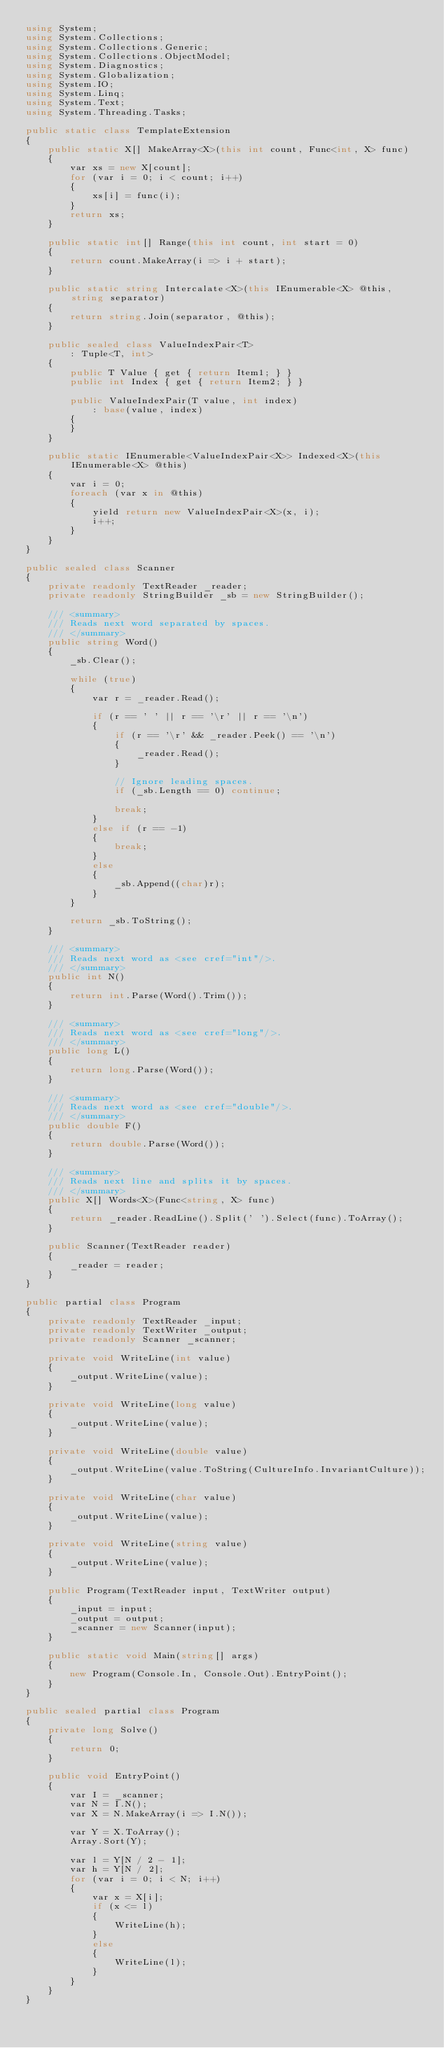<code> <loc_0><loc_0><loc_500><loc_500><_C#_>using System;
using System.Collections;
using System.Collections.Generic;
using System.Collections.ObjectModel;
using System.Diagnostics;
using System.Globalization;
using System.IO;
using System.Linq;
using System.Text;
using System.Threading.Tasks;

public static class TemplateExtension
{
    public static X[] MakeArray<X>(this int count, Func<int, X> func)
    {
        var xs = new X[count];
        for (var i = 0; i < count; i++)
        {
            xs[i] = func(i);
        }
        return xs;
    }

    public static int[] Range(this int count, int start = 0)
    {
        return count.MakeArray(i => i + start);
    }

    public static string Intercalate<X>(this IEnumerable<X> @this, string separator)
    {
        return string.Join(separator, @this);
    }

    public sealed class ValueIndexPair<T>
        : Tuple<T, int>
    {
        public T Value { get { return Item1; } }
        public int Index { get { return Item2; } }

        public ValueIndexPair(T value, int index)
            : base(value, index)
        {
        }
    }

    public static IEnumerable<ValueIndexPair<X>> Indexed<X>(this IEnumerable<X> @this)
    {
        var i = 0;
        foreach (var x in @this)
        {
            yield return new ValueIndexPair<X>(x, i);
            i++;
        }
    }
}

public sealed class Scanner
{
    private readonly TextReader _reader;
    private readonly StringBuilder _sb = new StringBuilder();

    /// <summary>
    /// Reads next word separated by spaces.
    /// </summary>
    public string Word()
    {
        _sb.Clear();

        while (true)
        {
            var r = _reader.Read();

            if (r == ' ' || r == '\r' || r == '\n')
            {
                if (r == '\r' && _reader.Peek() == '\n')
                {
                    _reader.Read();
                }

                // Ignore leading spaces.
                if (_sb.Length == 0) continue;

                break;
            }
            else if (r == -1)
            {
                break;
            }
            else
            {
                _sb.Append((char)r);
            }
        }

        return _sb.ToString();
    }

    /// <summary>
    /// Reads next word as <see cref="int"/>.
    /// </summary>
    public int N()
    {
        return int.Parse(Word().Trim());
    }

    /// <summary>
    /// Reads next word as <see cref="long"/>.
    /// </summary>
    public long L()
    {
        return long.Parse(Word());
    }

    /// <summary>
    /// Reads next word as <see cref="double"/>.
    /// </summary>
    public double F()
    {
        return double.Parse(Word());
    }

    /// <summary>
    /// Reads next line and splits it by spaces.
    /// </summary>
    public X[] Words<X>(Func<string, X> func)
    {
        return _reader.ReadLine().Split(' ').Select(func).ToArray();
    }

    public Scanner(TextReader reader)
    {
        _reader = reader;
    }
}

public partial class Program
{
    private readonly TextReader _input;
    private readonly TextWriter _output;
    private readonly Scanner _scanner;

    private void WriteLine(int value)
    {
        _output.WriteLine(value);
    }

    private void WriteLine(long value)
    {
        _output.WriteLine(value);
    }

    private void WriteLine(double value)
    {
        _output.WriteLine(value.ToString(CultureInfo.InvariantCulture));
    }

    private void WriteLine(char value)
    {
        _output.WriteLine(value);
    }

    private void WriteLine(string value)
    {
        _output.WriteLine(value);
    }

    public Program(TextReader input, TextWriter output)
    {
        _input = input;
        _output = output;
        _scanner = new Scanner(input);
    }

    public static void Main(string[] args)
    {
        new Program(Console.In, Console.Out).EntryPoint();
    }
}

public sealed partial class Program
{
    private long Solve()
    {
        return 0;
    }

    public void EntryPoint()
    {
        var I = _scanner;
        var N = I.N();
        var X = N.MakeArray(i => I.N());

        var Y = X.ToArray();
        Array.Sort(Y);

        var l = Y[N / 2 - 1];
        var h = Y[N / 2];
        for (var i = 0; i < N; i++)
        {
            var x = X[i];
            if (x <= l)
            {
                WriteLine(h);
            }
            else
            {
                WriteLine(l);
            }
        }
    }
}
</code> 